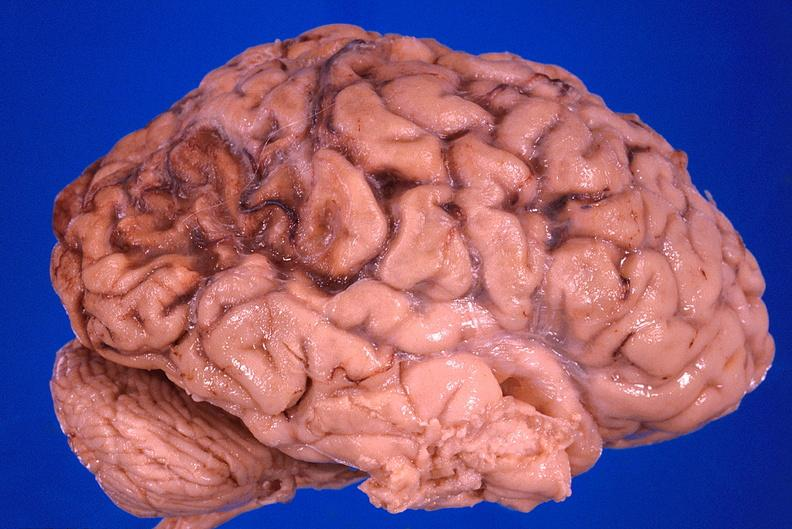s nervous present?
Answer the question using a single word or phrase. Yes 